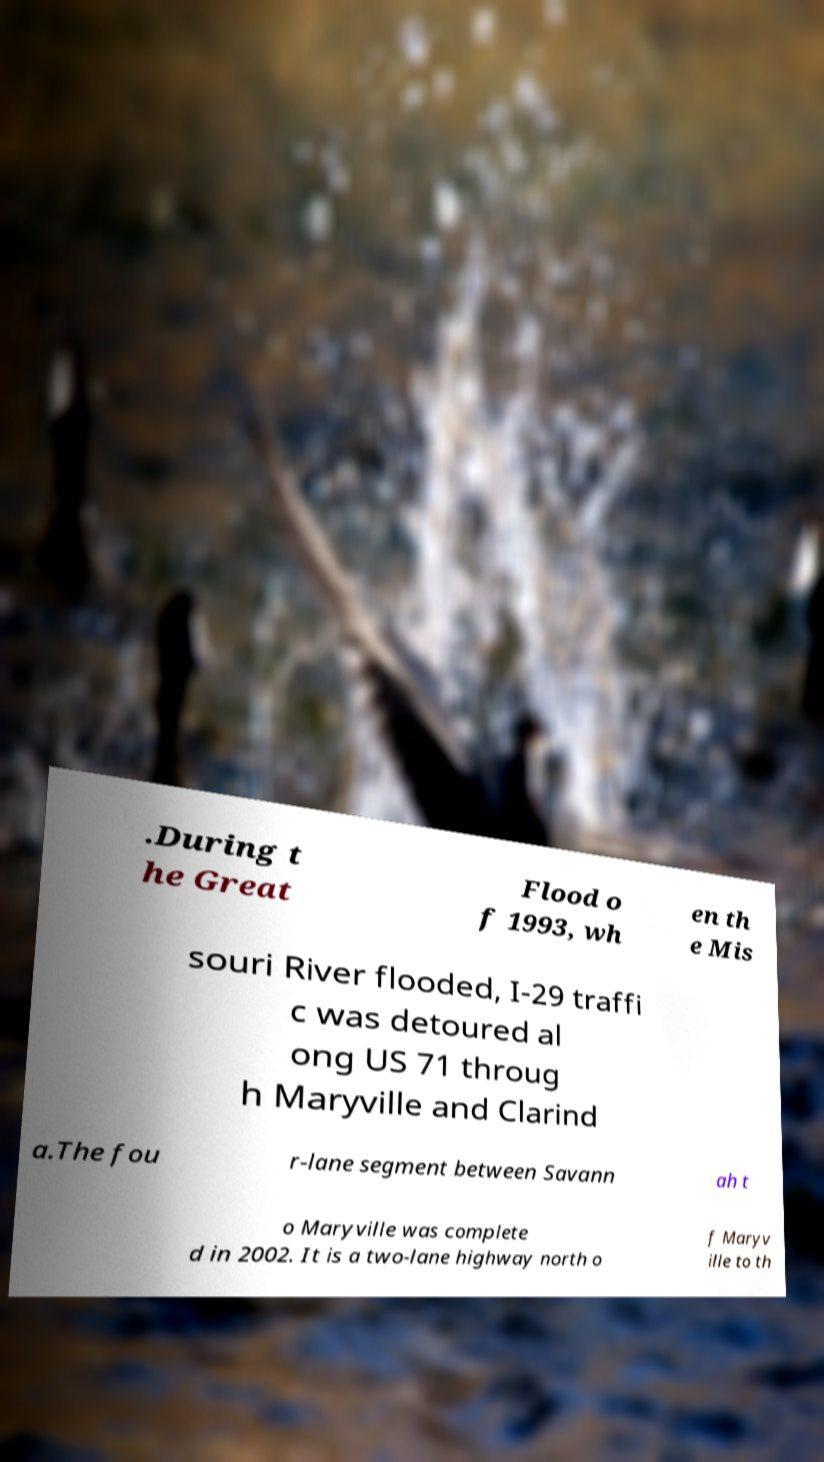Can you read and provide the text displayed in the image?This photo seems to have some interesting text. Can you extract and type it out for me? .During t he Great Flood o f 1993, wh en th e Mis souri River flooded, I-29 traffi c was detoured al ong US 71 throug h Maryville and Clarind a.The fou r-lane segment between Savann ah t o Maryville was complete d in 2002. It is a two-lane highway north o f Maryv ille to th 